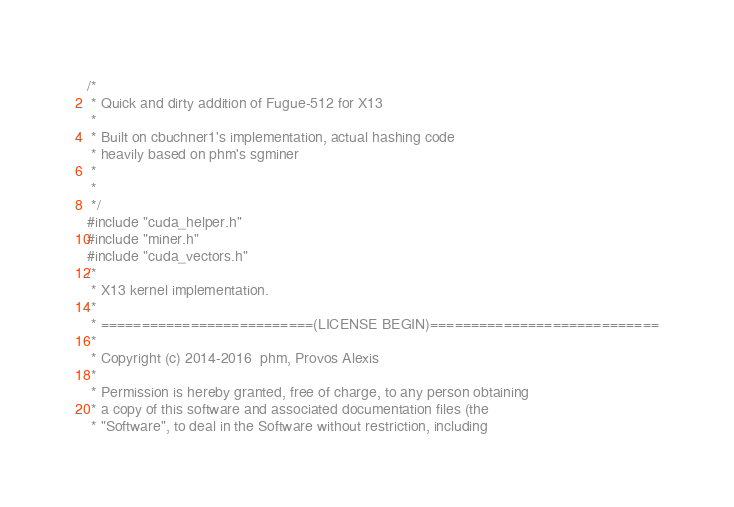<code> <loc_0><loc_0><loc_500><loc_500><_Cuda_>/*
 * Quick and dirty addition of Fugue-512 for X13
 * 
 * Built on cbuchner1's implementation, actual hashing code
 * heavily based on phm's sgminer
 *
 * 
 */
#include "cuda_helper.h"
#include "miner.h"
#include "cuda_vectors.h"
/*
 * X13 kernel implementation.
 *
 * ==========================(LICENSE BEGIN)============================
 *
 * Copyright (c) 2014-2016  phm, Provos Alexis
 * 
 * Permission is hereby granted, free of charge, to any person obtaining
 * a copy of this software and associated documentation files (the
 * "Software", to deal in the Software without restriction, including</code> 